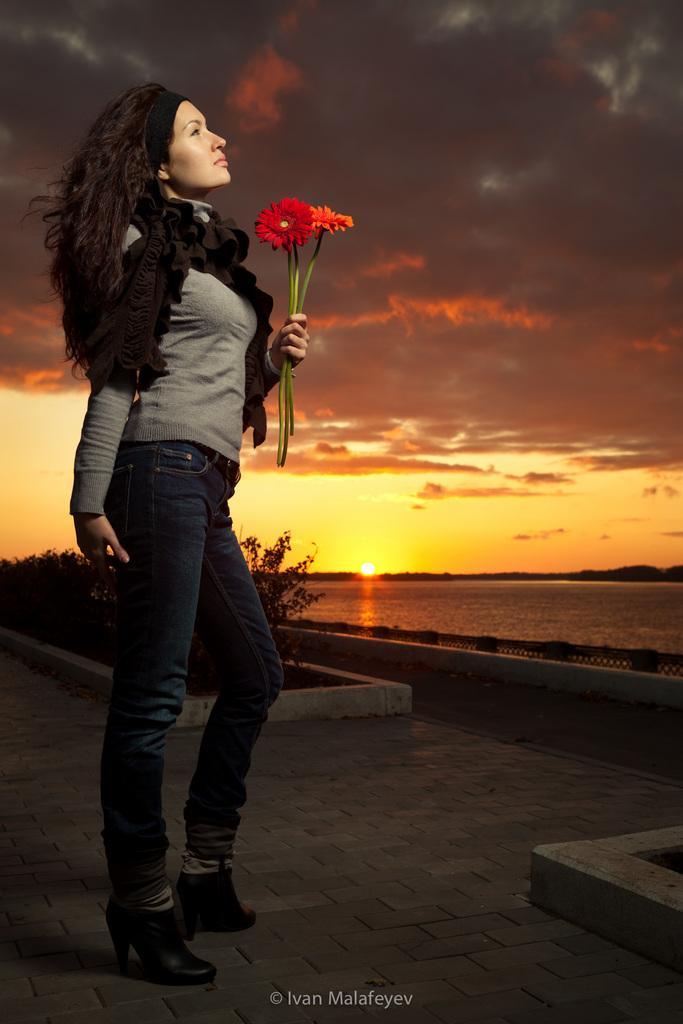How would you summarize this image in a sentence or two? In this picture there is a woman standing and holding the flowers. At the back there are plants and there is water. At the top there is sky and there are clouds and there is a sun. At the bottom there is a road and there is a text. 